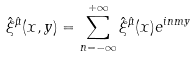Convert formula to latex. <formula><loc_0><loc_0><loc_500><loc_500>\hat { \xi } ^ { \hat { \mu } } ( x , y ) = \sum _ { n = - \infty } ^ { + \infty } \hat { \xi } ^ { \hat { \mu } } ( x ) e ^ { i n m y }</formula> 